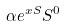Convert formula to latex. <formula><loc_0><loc_0><loc_500><loc_500>\alpha e ^ { x S } S ^ { 0 }</formula> 